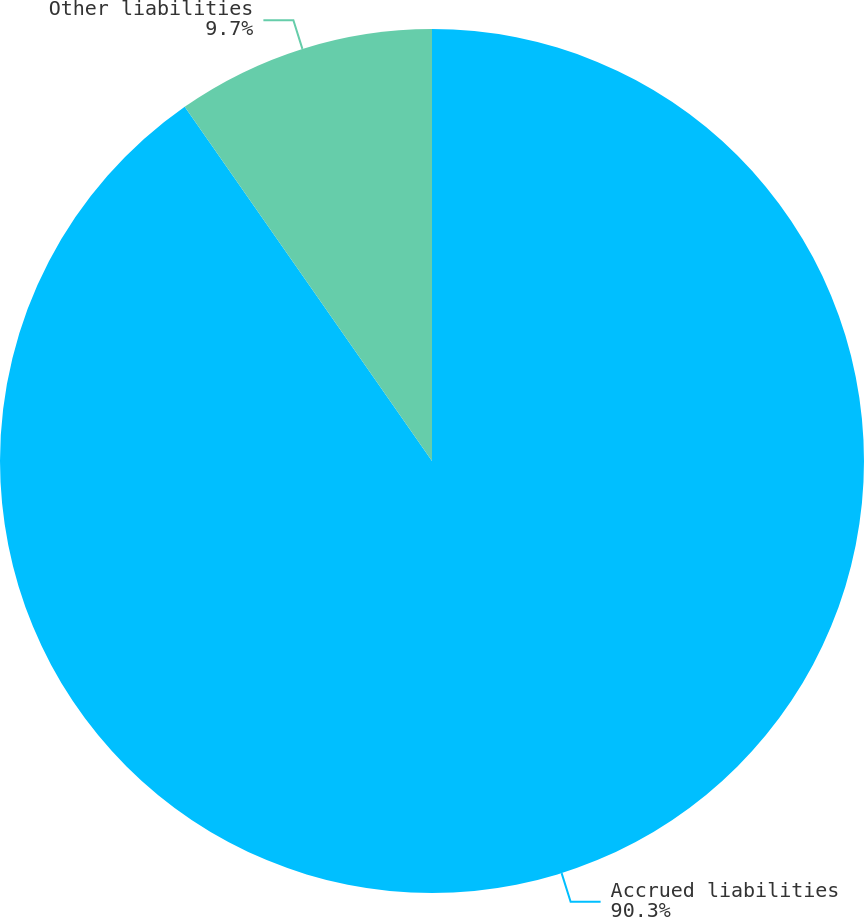Convert chart to OTSL. <chart><loc_0><loc_0><loc_500><loc_500><pie_chart><fcel>Accrued liabilities<fcel>Other liabilities<nl><fcel>90.3%<fcel>9.7%<nl></chart> 